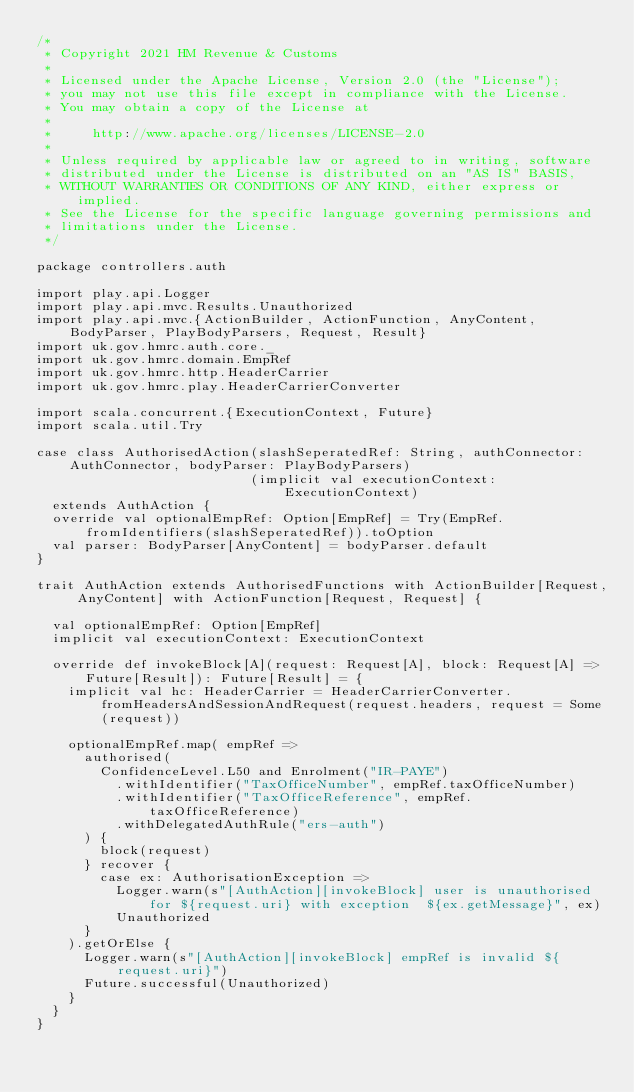<code> <loc_0><loc_0><loc_500><loc_500><_Scala_>/*
 * Copyright 2021 HM Revenue & Customs
 *
 * Licensed under the Apache License, Version 2.0 (the "License");
 * you may not use this file except in compliance with the License.
 * You may obtain a copy of the License at
 *
 *     http://www.apache.org/licenses/LICENSE-2.0
 *
 * Unless required by applicable law or agreed to in writing, software
 * distributed under the License is distributed on an "AS IS" BASIS,
 * WITHOUT WARRANTIES OR CONDITIONS OF ANY KIND, either express or implied.
 * See the License for the specific language governing permissions and
 * limitations under the License.
 */

package controllers.auth

import play.api.Logger
import play.api.mvc.Results.Unauthorized
import play.api.mvc.{ActionBuilder, ActionFunction, AnyContent, BodyParser, PlayBodyParsers, Request, Result}
import uk.gov.hmrc.auth.core._
import uk.gov.hmrc.domain.EmpRef
import uk.gov.hmrc.http.HeaderCarrier
import uk.gov.hmrc.play.HeaderCarrierConverter

import scala.concurrent.{ExecutionContext, Future}
import scala.util.Try

case class AuthorisedAction(slashSeperatedRef: String, authConnector: AuthConnector, bodyParser: PlayBodyParsers)
                           (implicit val executionContext: ExecutionContext)
  extends AuthAction {
  override val optionalEmpRef: Option[EmpRef] = Try(EmpRef.fromIdentifiers(slashSeperatedRef)).toOption
  val parser: BodyParser[AnyContent] = bodyParser.default
}

trait AuthAction extends AuthorisedFunctions with ActionBuilder[Request, AnyContent] with ActionFunction[Request, Request] {

  val optionalEmpRef: Option[EmpRef]
  implicit val executionContext: ExecutionContext

  override def invokeBlock[A](request: Request[A], block: Request[A] => Future[Result]): Future[Result] = {
    implicit val hc: HeaderCarrier = HeaderCarrierConverter.fromHeadersAndSessionAndRequest(request.headers, request = Some(request))

    optionalEmpRef.map( empRef =>
      authorised(
        ConfidenceLevel.L50 and Enrolment("IR-PAYE")
          .withIdentifier("TaxOfficeNumber", empRef.taxOfficeNumber)
          .withIdentifier("TaxOfficeReference", empRef.taxOfficeReference)
          .withDelegatedAuthRule("ers-auth")
      ) {
        block(request)
      } recover {
        case ex: AuthorisationException =>
          Logger.warn(s"[AuthAction][invokeBlock] user is unauthorised for ${request.uri} with exception  ${ex.getMessage}", ex)
          Unauthorized
      }
    ).getOrElse {
      Logger.warn(s"[AuthAction][invokeBlock] empRef is invalid ${request.uri}")
      Future.successful(Unauthorized)
    }
  }
}
</code> 